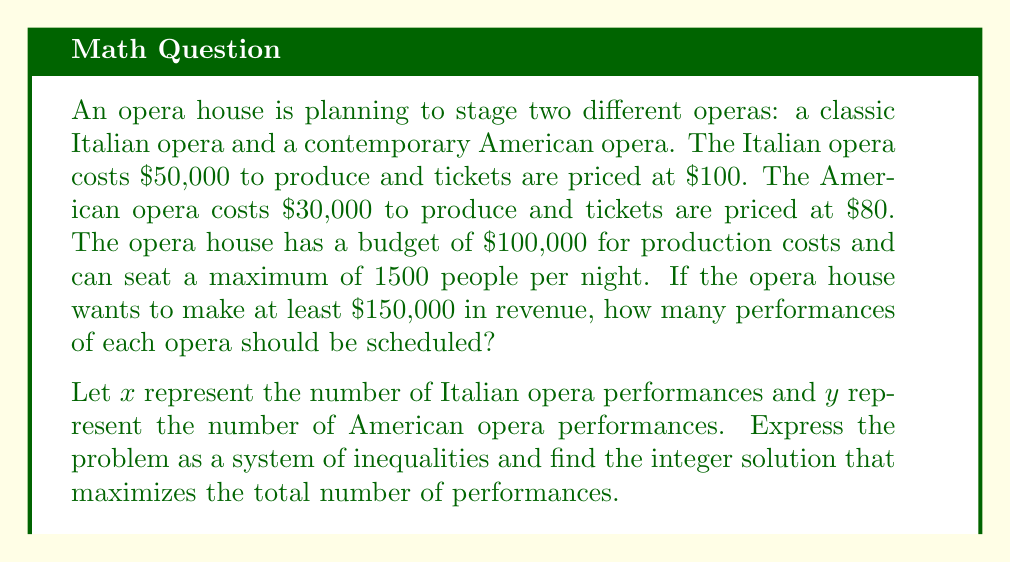Can you solve this math problem? To solve this problem, we need to set up a system of inequalities based on the given information and constraints:

1. Budget constraint:
   $50000x + 30000y \leq 100000$

2. Seating constraint:
   $1500x + 1500y \leq 1500$ (simplifies to $x + y \leq 1$)

3. Revenue constraint:
   $100 \cdot 1500x + 80 \cdot 1500y \geq 150000$
   (simplifies to $150000x + 120000y \geq 150000$)

4. Non-negativity constraints:
   $x \geq 0$, $y \geq 0$

Now, let's solve this system of inequalities:

Step 1: Simplify the inequalities
$$\begin{cases}
5x + 3y \leq 10 \\
x + y \leq 1 \\
5x + 4y \geq 5 \\
x \geq 0, y \geq 0
\end{cases}$$

Step 2: Graph the inequalities
[asy]
import graph;
size(200);
xaxis("x",0,2);
yaxis("y",0,2);

draw((0,10/3)--(2,0),blue);
draw((0,1)--(1,0),red);
draw((1,0)--(0,5/4),green);

fill((0,5/4)--(1,0)--(0,1)--cycle,palegreen+opacity(0.3));

label("5x + 3y = 10",(.75,1.5),NE,blue);
label("x + y = 1",(0.75,0.5),SE,red);
label("5x + 4y = 5",(0.6,0.8),SW,green);
[/asy]

Step 3: Identify the feasible region (shaded area in the graph)

Step 4: Find the integer points within the feasible region
The only integer point in the feasible region is (1, 0)

Step 5: Interpret the solution
This means the opera house should schedule 1 performance of the Italian opera and 0 performances of the American opera to maximize the total number of performances while meeting all constraints.

Step 6: Verify the solution
- Budget: $50000(1) + 30000(0) = 50000 \leq 100000$
- Seating: $1500(1) + 1500(0) = 1500 \leq 1500$
- Revenue: $100 \cdot 1500(1) + 80 \cdot 1500(0) = 150000 \geq 150000$

The solution satisfies all constraints.
Answer: 1 Italian opera performance, 0 American opera performances 